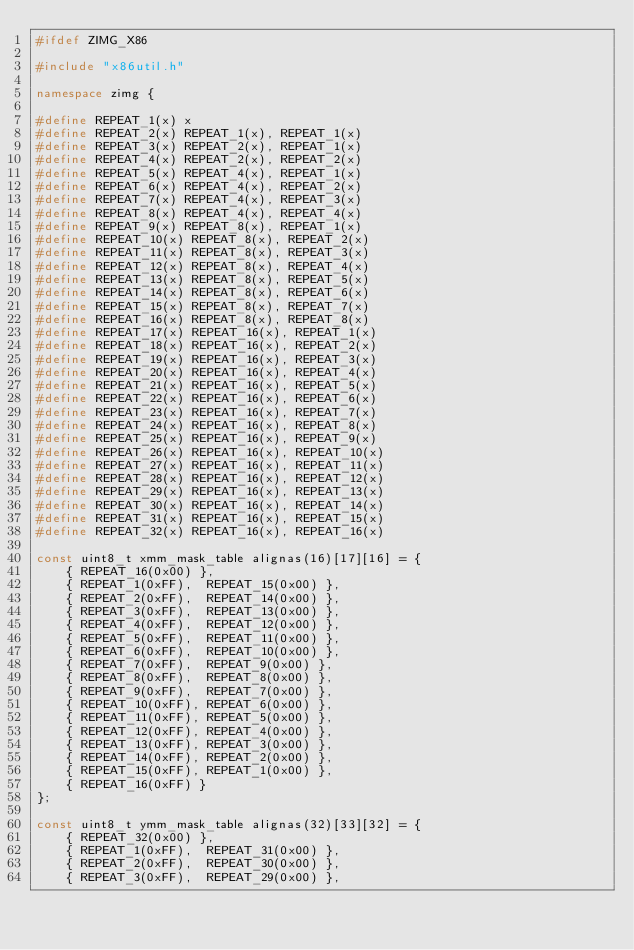Convert code to text. <code><loc_0><loc_0><loc_500><loc_500><_C++_>#ifdef ZIMG_X86

#include "x86util.h"

namespace zimg {

#define REPEAT_1(x) x
#define REPEAT_2(x) REPEAT_1(x), REPEAT_1(x)
#define REPEAT_3(x) REPEAT_2(x), REPEAT_1(x)
#define REPEAT_4(x) REPEAT_2(x), REPEAT_2(x)
#define REPEAT_5(x) REPEAT_4(x), REPEAT_1(x)
#define REPEAT_6(x) REPEAT_4(x), REPEAT_2(x)
#define REPEAT_7(x) REPEAT_4(x), REPEAT_3(x)
#define REPEAT_8(x) REPEAT_4(x), REPEAT_4(x)
#define REPEAT_9(x) REPEAT_8(x), REPEAT_1(x)
#define REPEAT_10(x) REPEAT_8(x), REPEAT_2(x)
#define REPEAT_11(x) REPEAT_8(x), REPEAT_3(x)
#define REPEAT_12(x) REPEAT_8(x), REPEAT_4(x)
#define REPEAT_13(x) REPEAT_8(x), REPEAT_5(x)
#define REPEAT_14(x) REPEAT_8(x), REPEAT_6(x)
#define REPEAT_15(x) REPEAT_8(x), REPEAT_7(x)
#define REPEAT_16(x) REPEAT_8(x), REPEAT_8(x)
#define REPEAT_17(x) REPEAT_16(x), REPEAT_1(x)
#define REPEAT_18(x) REPEAT_16(x), REPEAT_2(x)
#define REPEAT_19(x) REPEAT_16(x), REPEAT_3(x)
#define REPEAT_20(x) REPEAT_16(x), REPEAT_4(x)
#define REPEAT_21(x) REPEAT_16(x), REPEAT_5(x)
#define REPEAT_22(x) REPEAT_16(x), REPEAT_6(x)
#define REPEAT_23(x) REPEAT_16(x), REPEAT_7(x)
#define REPEAT_24(x) REPEAT_16(x), REPEAT_8(x)
#define REPEAT_25(x) REPEAT_16(x), REPEAT_9(x)
#define REPEAT_26(x) REPEAT_16(x), REPEAT_10(x)
#define REPEAT_27(x) REPEAT_16(x), REPEAT_11(x)
#define REPEAT_28(x) REPEAT_16(x), REPEAT_12(x)
#define REPEAT_29(x) REPEAT_16(x), REPEAT_13(x)
#define REPEAT_30(x) REPEAT_16(x), REPEAT_14(x)
#define REPEAT_31(x) REPEAT_16(x), REPEAT_15(x)
#define REPEAT_32(x) REPEAT_16(x), REPEAT_16(x)

const uint8_t xmm_mask_table alignas(16)[17][16] = {
	{ REPEAT_16(0x00) },
	{ REPEAT_1(0xFF),  REPEAT_15(0x00) },
	{ REPEAT_2(0xFF),  REPEAT_14(0x00) },
	{ REPEAT_3(0xFF),  REPEAT_13(0x00) },
	{ REPEAT_4(0xFF),  REPEAT_12(0x00) },
	{ REPEAT_5(0xFF),  REPEAT_11(0x00) },
	{ REPEAT_6(0xFF),  REPEAT_10(0x00) },
	{ REPEAT_7(0xFF),  REPEAT_9(0x00) },
	{ REPEAT_8(0xFF),  REPEAT_8(0x00) },
	{ REPEAT_9(0xFF),  REPEAT_7(0x00) },
	{ REPEAT_10(0xFF), REPEAT_6(0x00) },
	{ REPEAT_11(0xFF), REPEAT_5(0x00) },
	{ REPEAT_12(0xFF), REPEAT_4(0x00) },
	{ REPEAT_13(0xFF), REPEAT_3(0x00) },
	{ REPEAT_14(0xFF), REPEAT_2(0x00) },
	{ REPEAT_15(0xFF), REPEAT_1(0x00) },
	{ REPEAT_16(0xFF) }
};

const uint8_t ymm_mask_table alignas(32)[33][32] = {
	{ REPEAT_32(0x00) },
	{ REPEAT_1(0xFF),  REPEAT_31(0x00) },
	{ REPEAT_2(0xFF),  REPEAT_30(0x00) },
	{ REPEAT_3(0xFF),  REPEAT_29(0x00) },</code> 